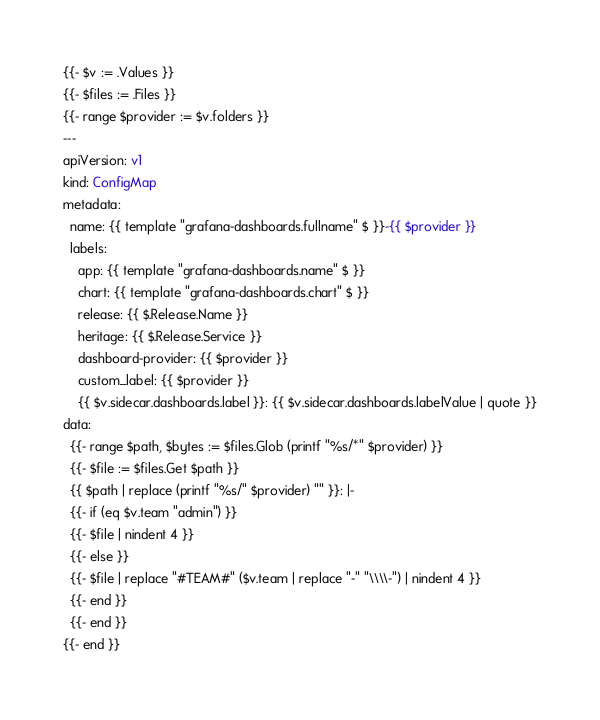<code> <loc_0><loc_0><loc_500><loc_500><_YAML_>{{- $v := .Values }}
{{- $files := .Files }}
{{- range $provider := $v.folders }}
---
apiVersion: v1
kind: ConfigMap
metadata:
  name: {{ template "grafana-dashboards.fullname" $ }}-{{ $provider }}
  labels:
    app: {{ template "grafana-dashboards.name" $ }}
    chart: {{ template "grafana-dashboards.chart" $ }}
    release: {{ $.Release.Name }}
    heritage: {{ $.Release.Service }}
    dashboard-provider: {{ $provider }}
    custom_label: {{ $provider }}
    {{ $v.sidecar.dashboards.label }}: {{ $v.sidecar.dashboards.labelValue | quote }}
data:
  {{- range $path, $bytes := $files.Glob (printf "%s/*" $provider) }}
  {{- $file := $files.Get $path }}
  {{ $path | replace (printf "%s/" $provider) "" }}: |-
  {{- if (eq $v.team "admin") }}
  {{- $file | nindent 4 }}
  {{- else }}
  {{- $file | replace "#TEAM#" ($v.team | replace "-" "\\\\-") | nindent 4 }}
  {{- end }}
  {{- end }}
{{- end }}
</code> 